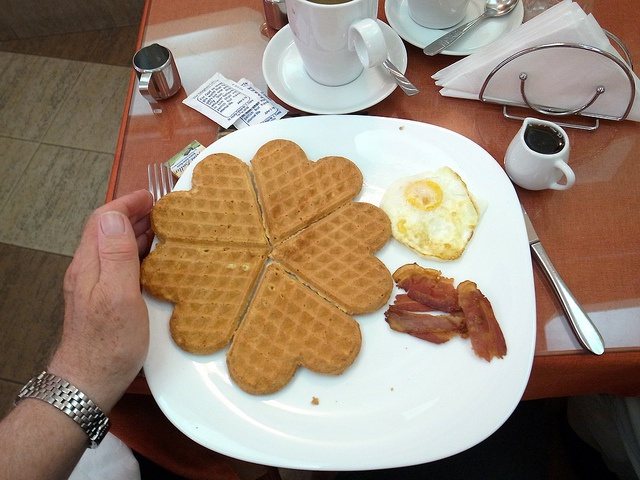Describe the objects in this image and their specific colors. I can see dining table in black, brown, and maroon tones, people in black, gray, salmon, and maroon tones, cup in black, darkgray, and lightgray tones, cup in black, darkgray, lightgray, and gray tones, and knife in black, white, darkgray, and gray tones in this image. 